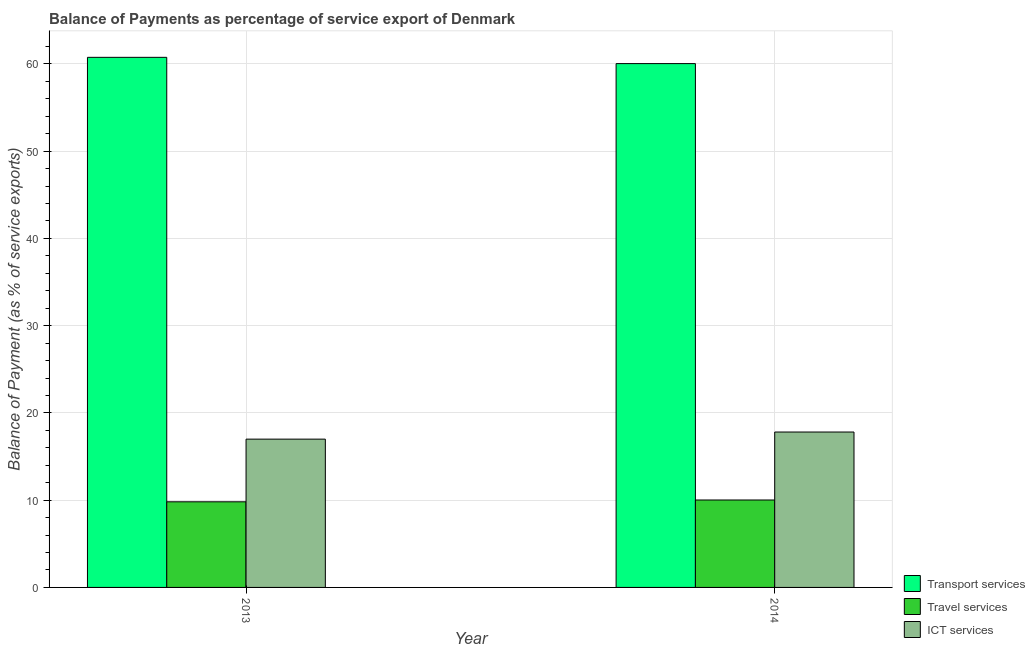How many bars are there on the 1st tick from the left?
Offer a very short reply. 3. What is the label of the 2nd group of bars from the left?
Provide a short and direct response. 2014. In how many cases, is the number of bars for a given year not equal to the number of legend labels?
Provide a short and direct response. 0. What is the balance of payment of travel services in 2013?
Give a very brief answer. 9.81. Across all years, what is the maximum balance of payment of transport services?
Provide a succinct answer. 60.75. Across all years, what is the minimum balance of payment of travel services?
Your answer should be compact. 9.81. In which year was the balance of payment of travel services maximum?
Give a very brief answer. 2014. In which year was the balance of payment of travel services minimum?
Your answer should be compact. 2013. What is the total balance of payment of transport services in the graph?
Ensure brevity in your answer.  120.78. What is the difference between the balance of payment of travel services in 2013 and that in 2014?
Your answer should be compact. -0.21. What is the difference between the balance of payment of travel services in 2014 and the balance of payment of transport services in 2013?
Make the answer very short. 0.21. What is the average balance of payment of ict services per year?
Provide a succinct answer. 17.4. In how many years, is the balance of payment of transport services greater than 26 %?
Your answer should be compact. 2. What is the ratio of the balance of payment of transport services in 2013 to that in 2014?
Your answer should be very brief. 1.01. What does the 1st bar from the left in 2013 represents?
Offer a terse response. Transport services. What does the 1st bar from the right in 2013 represents?
Your answer should be very brief. ICT services. How many years are there in the graph?
Your answer should be compact. 2. What is the difference between two consecutive major ticks on the Y-axis?
Make the answer very short. 10. Does the graph contain any zero values?
Your answer should be compact. No. Does the graph contain grids?
Your answer should be compact. Yes. How are the legend labels stacked?
Offer a terse response. Vertical. What is the title of the graph?
Make the answer very short. Balance of Payments as percentage of service export of Denmark. What is the label or title of the Y-axis?
Provide a short and direct response. Balance of Payment (as % of service exports). What is the Balance of Payment (as % of service exports) of Transport services in 2013?
Your answer should be very brief. 60.75. What is the Balance of Payment (as % of service exports) of Travel services in 2013?
Your response must be concise. 9.81. What is the Balance of Payment (as % of service exports) in ICT services in 2013?
Offer a terse response. 16.99. What is the Balance of Payment (as % of service exports) in Transport services in 2014?
Ensure brevity in your answer.  60.03. What is the Balance of Payment (as % of service exports) in Travel services in 2014?
Your response must be concise. 10.02. What is the Balance of Payment (as % of service exports) of ICT services in 2014?
Make the answer very short. 17.81. Across all years, what is the maximum Balance of Payment (as % of service exports) of Transport services?
Your response must be concise. 60.75. Across all years, what is the maximum Balance of Payment (as % of service exports) of Travel services?
Make the answer very short. 10.02. Across all years, what is the maximum Balance of Payment (as % of service exports) in ICT services?
Keep it short and to the point. 17.81. Across all years, what is the minimum Balance of Payment (as % of service exports) of Transport services?
Provide a succinct answer. 60.03. Across all years, what is the minimum Balance of Payment (as % of service exports) of Travel services?
Make the answer very short. 9.81. Across all years, what is the minimum Balance of Payment (as % of service exports) in ICT services?
Ensure brevity in your answer.  16.99. What is the total Balance of Payment (as % of service exports) in Transport services in the graph?
Your answer should be very brief. 120.78. What is the total Balance of Payment (as % of service exports) of Travel services in the graph?
Give a very brief answer. 19.83. What is the total Balance of Payment (as % of service exports) of ICT services in the graph?
Provide a succinct answer. 34.8. What is the difference between the Balance of Payment (as % of service exports) of Transport services in 2013 and that in 2014?
Provide a succinct answer. 0.72. What is the difference between the Balance of Payment (as % of service exports) in Travel services in 2013 and that in 2014?
Provide a short and direct response. -0.21. What is the difference between the Balance of Payment (as % of service exports) in ICT services in 2013 and that in 2014?
Ensure brevity in your answer.  -0.81. What is the difference between the Balance of Payment (as % of service exports) in Transport services in 2013 and the Balance of Payment (as % of service exports) in Travel services in 2014?
Offer a terse response. 50.73. What is the difference between the Balance of Payment (as % of service exports) of Transport services in 2013 and the Balance of Payment (as % of service exports) of ICT services in 2014?
Your response must be concise. 42.94. What is the difference between the Balance of Payment (as % of service exports) in Travel services in 2013 and the Balance of Payment (as % of service exports) in ICT services in 2014?
Offer a very short reply. -8. What is the average Balance of Payment (as % of service exports) in Transport services per year?
Offer a terse response. 60.39. What is the average Balance of Payment (as % of service exports) of Travel services per year?
Your answer should be compact. 9.92. What is the average Balance of Payment (as % of service exports) in ICT services per year?
Give a very brief answer. 17.4. In the year 2013, what is the difference between the Balance of Payment (as % of service exports) in Transport services and Balance of Payment (as % of service exports) in Travel services?
Give a very brief answer. 50.94. In the year 2013, what is the difference between the Balance of Payment (as % of service exports) of Transport services and Balance of Payment (as % of service exports) of ICT services?
Provide a succinct answer. 43.75. In the year 2013, what is the difference between the Balance of Payment (as % of service exports) in Travel services and Balance of Payment (as % of service exports) in ICT services?
Keep it short and to the point. -7.18. In the year 2014, what is the difference between the Balance of Payment (as % of service exports) in Transport services and Balance of Payment (as % of service exports) in Travel services?
Keep it short and to the point. 50.01. In the year 2014, what is the difference between the Balance of Payment (as % of service exports) of Transport services and Balance of Payment (as % of service exports) of ICT services?
Offer a terse response. 42.22. In the year 2014, what is the difference between the Balance of Payment (as % of service exports) in Travel services and Balance of Payment (as % of service exports) in ICT services?
Provide a short and direct response. -7.79. What is the ratio of the Balance of Payment (as % of service exports) in Transport services in 2013 to that in 2014?
Make the answer very short. 1.01. What is the ratio of the Balance of Payment (as % of service exports) in Travel services in 2013 to that in 2014?
Your answer should be compact. 0.98. What is the ratio of the Balance of Payment (as % of service exports) of ICT services in 2013 to that in 2014?
Your answer should be compact. 0.95. What is the difference between the highest and the second highest Balance of Payment (as % of service exports) in Transport services?
Your response must be concise. 0.72. What is the difference between the highest and the second highest Balance of Payment (as % of service exports) in Travel services?
Your response must be concise. 0.21. What is the difference between the highest and the second highest Balance of Payment (as % of service exports) in ICT services?
Offer a terse response. 0.81. What is the difference between the highest and the lowest Balance of Payment (as % of service exports) of Transport services?
Give a very brief answer. 0.72. What is the difference between the highest and the lowest Balance of Payment (as % of service exports) of Travel services?
Provide a short and direct response. 0.21. What is the difference between the highest and the lowest Balance of Payment (as % of service exports) in ICT services?
Offer a terse response. 0.81. 